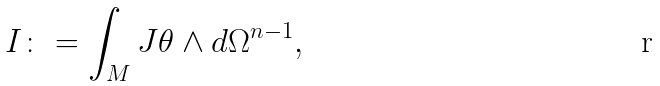Convert formula to latex. <formula><loc_0><loc_0><loc_500><loc_500>I \colon = \int _ { M } J \theta \wedge d \Omega ^ { n - 1 } ,</formula> 